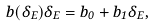<formula> <loc_0><loc_0><loc_500><loc_500>b ( \delta _ { E } ) \delta _ { E } = b _ { 0 } + b _ { 1 } \delta _ { E } ,</formula> 